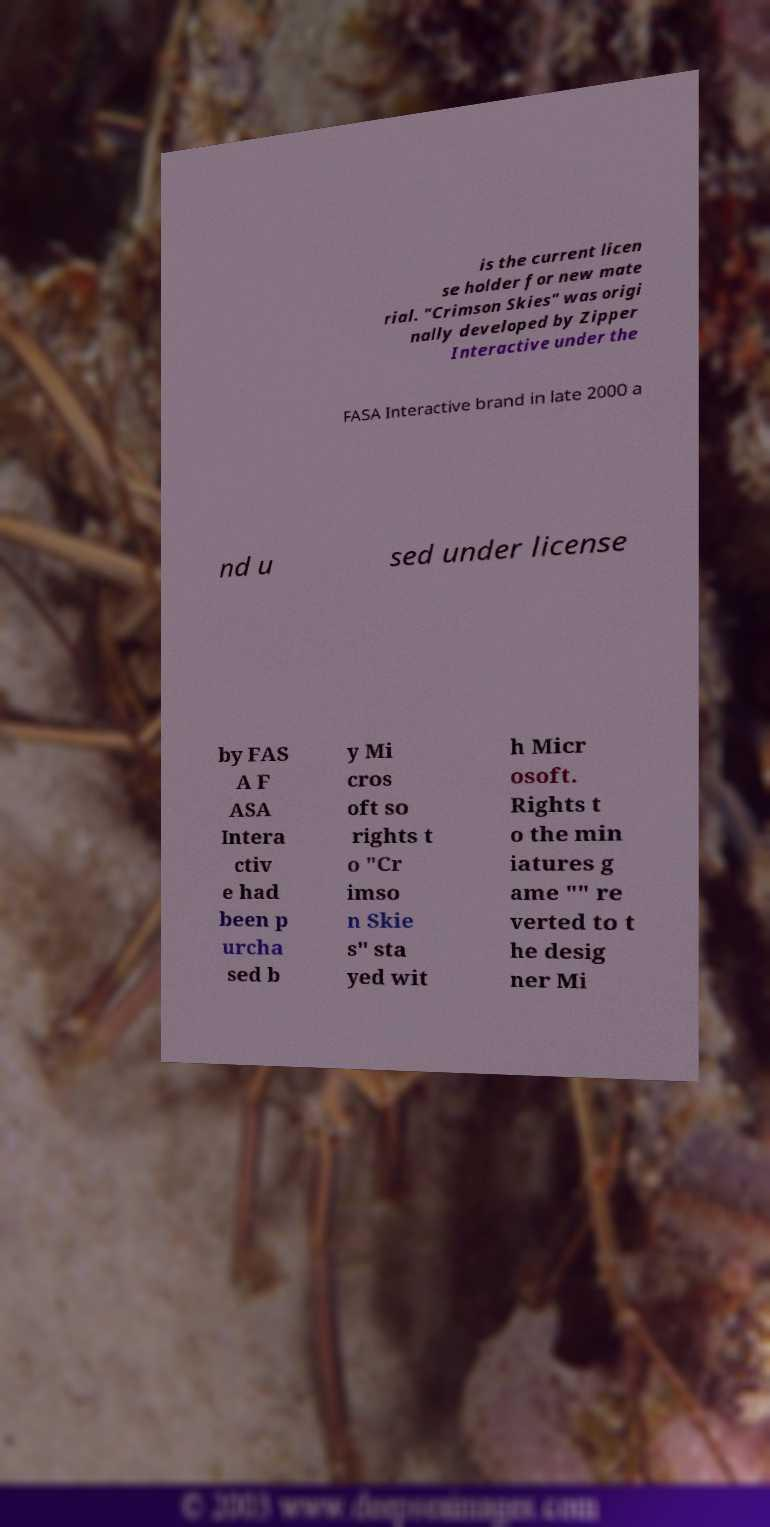What messages or text are displayed in this image? I need them in a readable, typed format. is the current licen se holder for new mate rial. "Crimson Skies" was origi nally developed by Zipper Interactive under the FASA Interactive brand in late 2000 a nd u sed under license by FAS A F ASA Intera ctiv e had been p urcha sed b y Mi cros oft so rights t o "Cr imso n Skie s" sta yed wit h Micr osoft. Rights t o the min iatures g ame "" re verted to t he desig ner Mi 